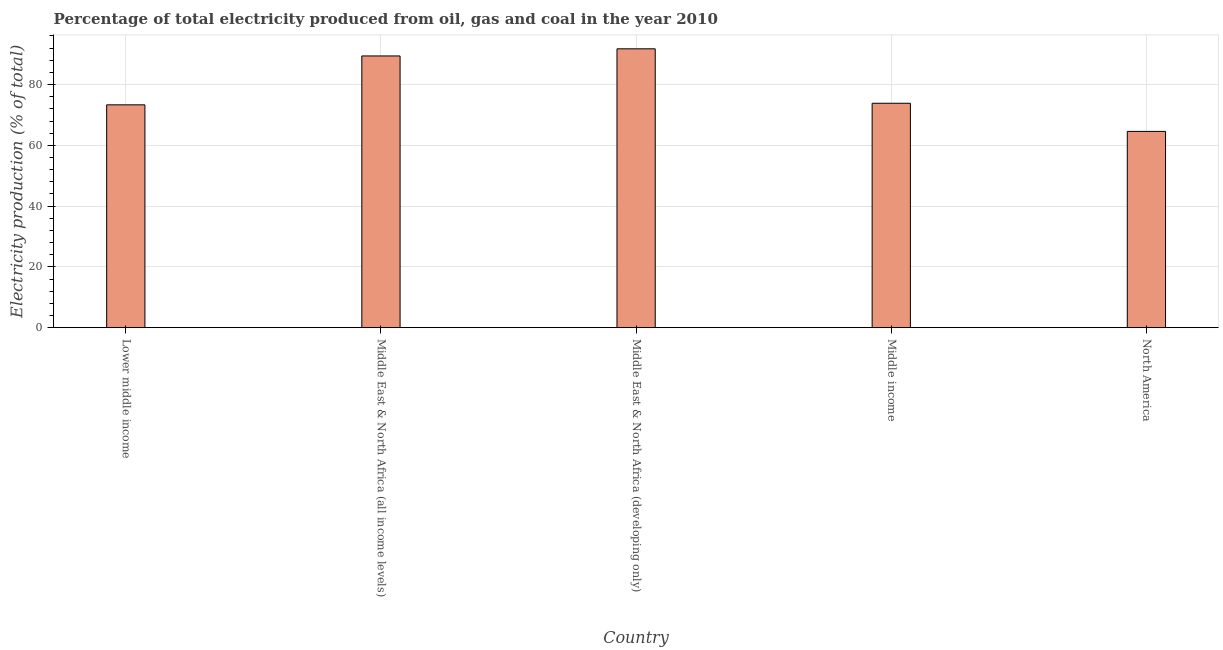What is the title of the graph?
Your response must be concise. Percentage of total electricity produced from oil, gas and coal in the year 2010. What is the label or title of the X-axis?
Offer a terse response. Country. What is the label or title of the Y-axis?
Offer a very short reply. Electricity production (% of total). What is the electricity production in Lower middle income?
Give a very brief answer. 73.32. Across all countries, what is the maximum electricity production?
Give a very brief answer. 91.76. Across all countries, what is the minimum electricity production?
Provide a succinct answer. 64.59. In which country was the electricity production maximum?
Ensure brevity in your answer.  Middle East & North Africa (developing only). What is the sum of the electricity production?
Provide a short and direct response. 392.92. What is the difference between the electricity production in Lower middle income and Middle East & North Africa (developing only)?
Provide a succinct answer. -18.43. What is the average electricity production per country?
Your answer should be compact. 78.58. What is the median electricity production?
Keep it short and to the point. 73.84. What is the ratio of the electricity production in Lower middle income to that in Middle East & North Africa (all income levels)?
Your answer should be very brief. 0.82. Is the electricity production in Lower middle income less than that in North America?
Ensure brevity in your answer.  No. Is the difference between the electricity production in Lower middle income and Middle East & North Africa (developing only) greater than the difference between any two countries?
Your response must be concise. No. What is the difference between the highest and the second highest electricity production?
Your response must be concise. 2.34. Is the sum of the electricity production in Middle income and North America greater than the maximum electricity production across all countries?
Provide a short and direct response. Yes. What is the difference between the highest and the lowest electricity production?
Provide a short and direct response. 27.17. How many bars are there?
Ensure brevity in your answer.  5. Are all the bars in the graph horizontal?
Make the answer very short. No. What is the Electricity production (% of total) in Lower middle income?
Your answer should be very brief. 73.32. What is the Electricity production (% of total) in Middle East & North Africa (all income levels)?
Offer a terse response. 89.41. What is the Electricity production (% of total) of Middle East & North Africa (developing only)?
Ensure brevity in your answer.  91.76. What is the Electricity production (% of total) in Middle income?
Give a very brief answer. 73.84. What is the Electricity production (% of total) of North America?
Ensure brevity in your answer.  64.59. What is the difference between the Electricity production (% of total) in Lower middle income and Middle East & North Africa (all income levels)?
Your answer should be very brief. -16.09. What is the difference between the Electricity production (% of total) in Lower middle income and Middle East & North Africa (developing only)?
Keep it short and to the point. -18.44. What is the difference between the Electricity production (% of total) in Lower middle income and Middle income?
Your response must be concise. -0.52. What is the difference between the Electricity production (% of total) in Lower middle income and North America?
Give a very brief answer. 8.74. What is the difference between the Electricity production (% of total) in Middle East & North Africa (all income levels) and Middle East & North Africa (developing only)?
Ensure brevity in your answer.  -2.34. What is the difference between the Electricity production (% of total) in Middle East & North Africa (all income levels) and Middle income?
Offer a very short reply. 15.57. What is the difference between the Electricity production (% of total) in Middle East & North Africa (all income levels) and North America?
Ensure brevity in your answer.  24.83. What is the difference between the Electricity production (% of total) in Middle East & North Africa (developing only) and Middle income?
Your answer should be very brief. 17.92. What is the difference between the Electricity production (% of total) in Middle East & North Africa (developing only) and North America?
Ensure brevity in your answer.  27.17. What is the difference between the Electricity production (% of total) in Middle income and North America?
Your answer should be very brief. 9.26. What is the ratio of the Electricity production (% of total) in Lower middle income to that in Middle East & North Africa (all income levels)?
Keep it short and to the point. 0.82. What is the ratio of the Electricity production (% of total) in Lower middle income to that in Middle East & North Africa (developing only)?
Your answer should be compact. 0.8. What is the ratio of the Electricity production (% of total) in Lower middle income to that in Middle income?
Your answer should be compact. 0.99. What is the ratio of the Electricity production (% of total) in Lower middle income to that in North America?
Your response must be concise. 1.14. What is the ratio of the Electricity production (% of total) in Middle East & North Africa (all income levels) to that in Middle income?
Offer a terse response. 1.21. What is the ratio of the Electricity production (% of total) in Middle East & North Africa (all income levels) to that in North America?
Make the answer very short. 1.38. What is the ratio of the Electricity production (% of total) in Middle East & North Africa (developing only) to that in Middle income?
Provide a succinct answer. 1.24. What is the ratio of the Electricity production (% of total) in Middle East & North Africa (developing only) to that in North America?
Provide a short and direct response. 1.42. What is the ratio of the Electricity production (% of total) in Middle income to that in North America?
Offer a terse response. 1.14. 